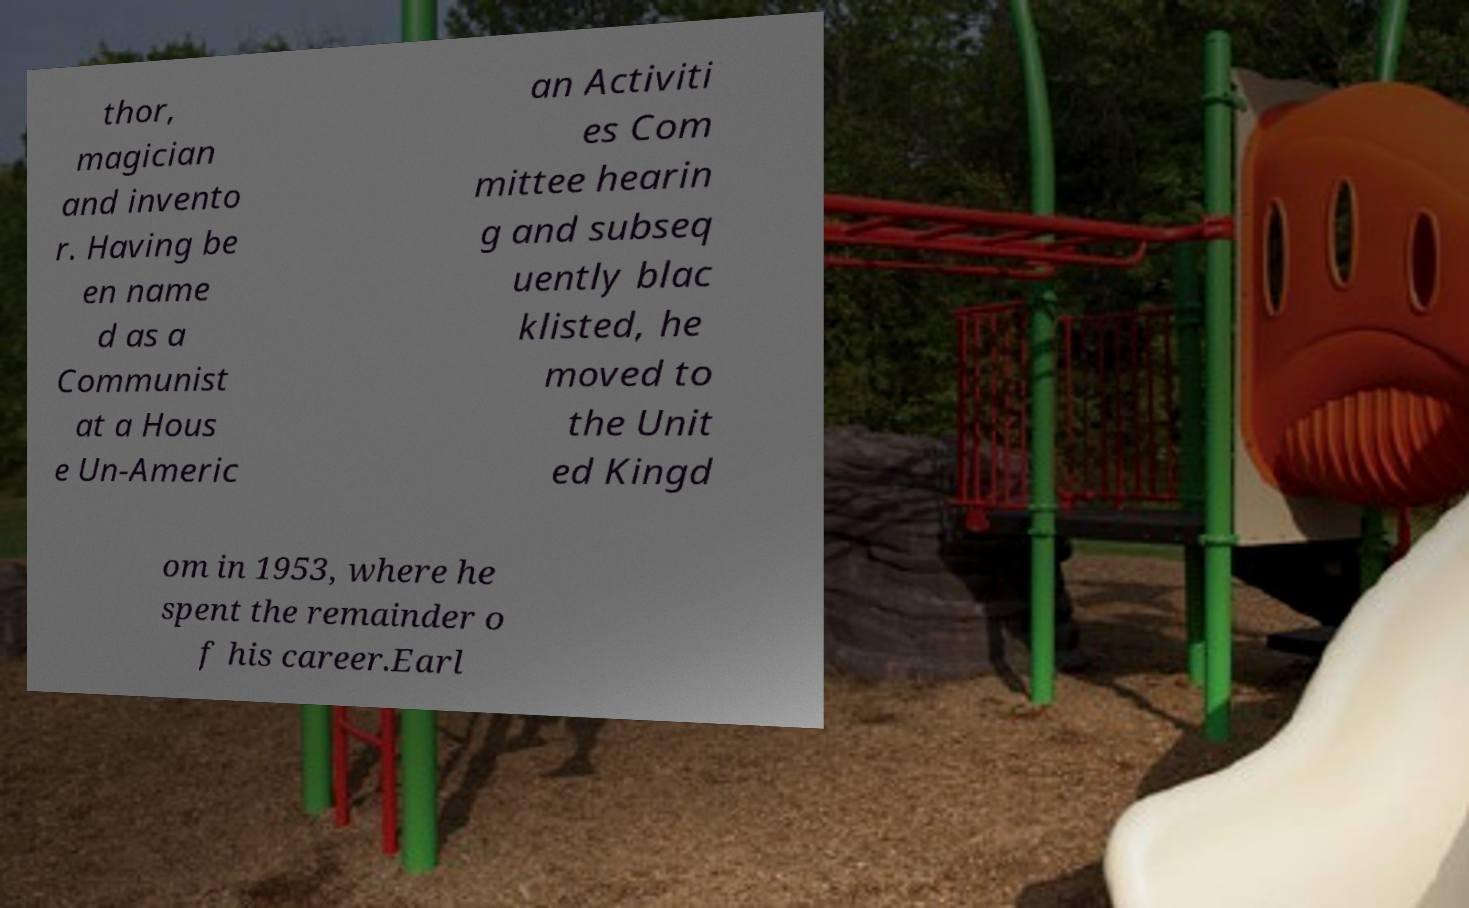Please read and relay the text visible in this image. What does it say? thor, magician and invento r. Having be en name d as a Communist at a Hous e Un-Americ an Activiti es Com mittee hearin g and subseq uently blac klisted, he moved to the Unit ed Kingd om in 1953, where he spent the remainder o f his career.Earl 